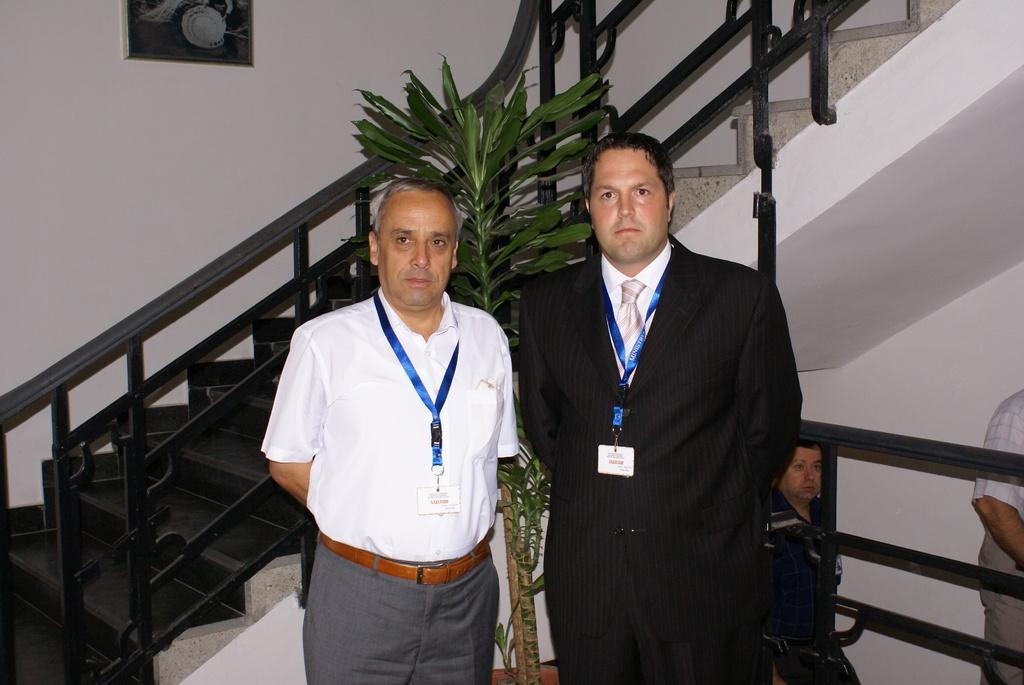What are the people in the image wearing? The persons in the image are wearing clothes. What can be seen in front of the staircase? There is a plant in front of the staircase. What is hanging on the wall in the image? There is a photo frame on the wall. What type of base is supporting the persons in the image? There is no base present in the image; the persons are standing on the ground. What meal is being prepared in the image? There is no meal preparation visible in the image. 